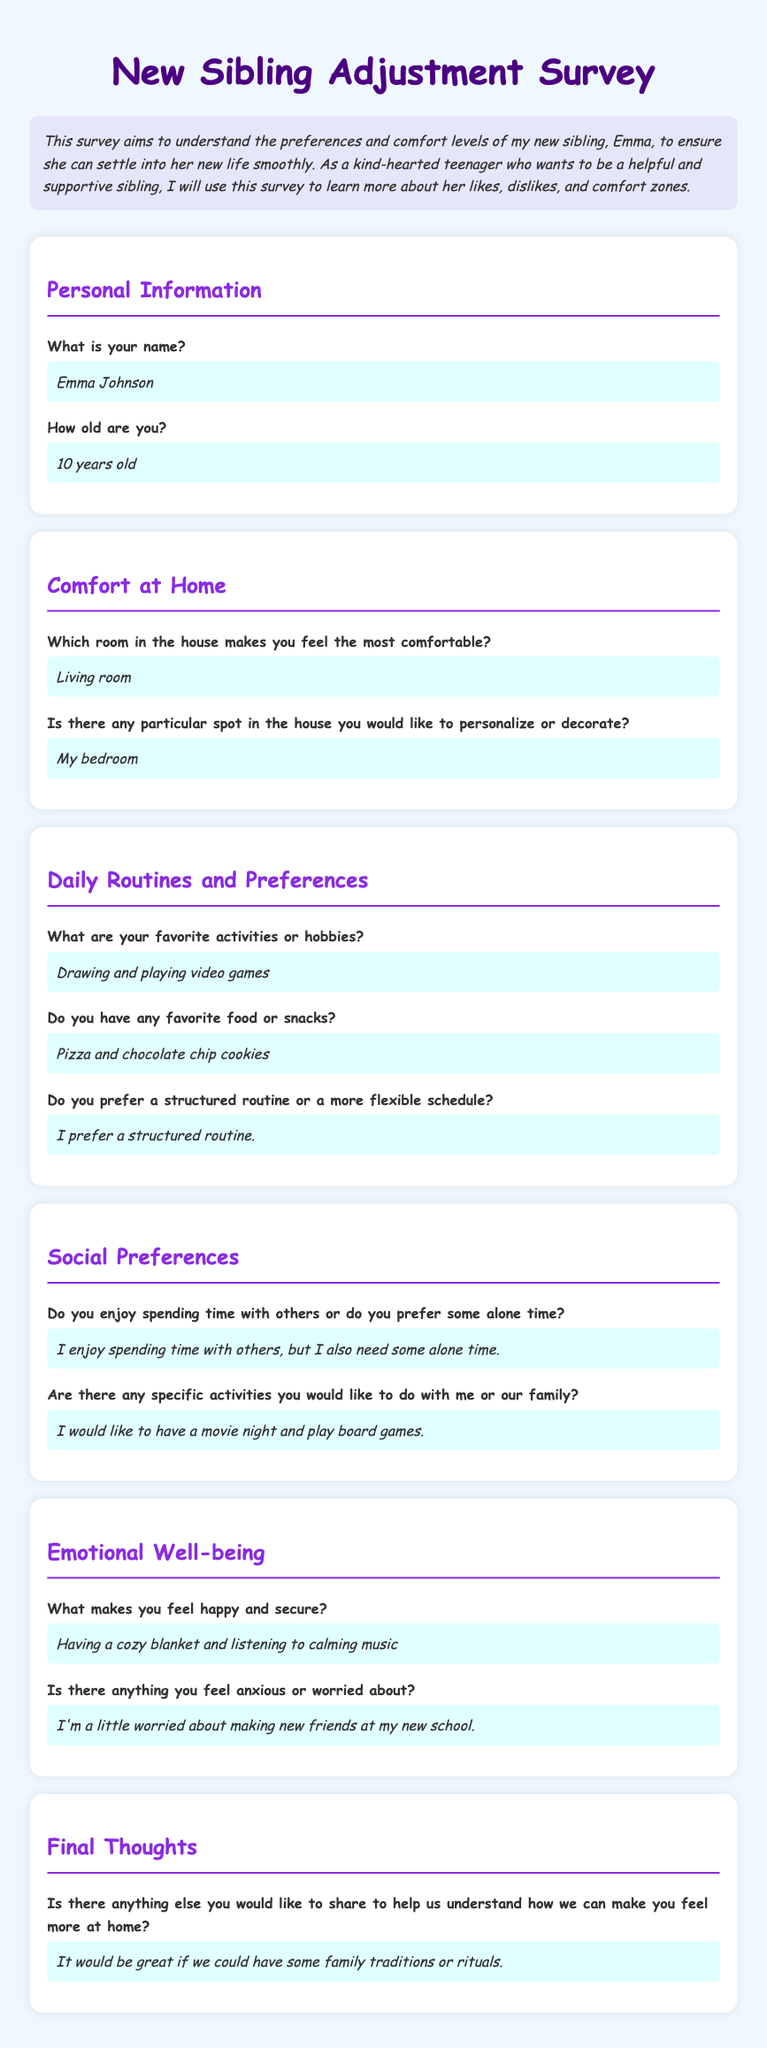What is Emma's full name? Emma's full name is stated in the personal information section of the survey.
Answer: Emma Johnson How old is Emma? Emma's age is provided directly in the survey.
Answer: 10 years old Which room in the house does Emma feel the most comfortable? Emma's comfort spot in the house is mentioned under the comfort at home section.
Answer: Living room What are Emma's favorite activities? The favorite activities are listed in the daily routines and preferences section.
Answer: Drawing and playing video games What food does Emma prefer? Emma's favorite snacks are mentioned in the daily routines and preferences section.
Answer: Pizza and chocolate chip cookies What makes Emma feel happy and secure? This is shared in the emotional well-being section of the survey.
Answer: Having a cozy blanket and listening to calming music What is Emma worried about? The concern of Emma is expressed in the emotional well-being section.
Answer: Making new friends at my new school What family activity does Emma want to do? Emma's desired family activity is stated in the social preferences section.
Answer: Have a movie night and play board games Is there anything Emma would like to share for feeling more at home? The final thoughts section includes Emma's thoughts on family traditions.
Answer: Family traditions or rituals 